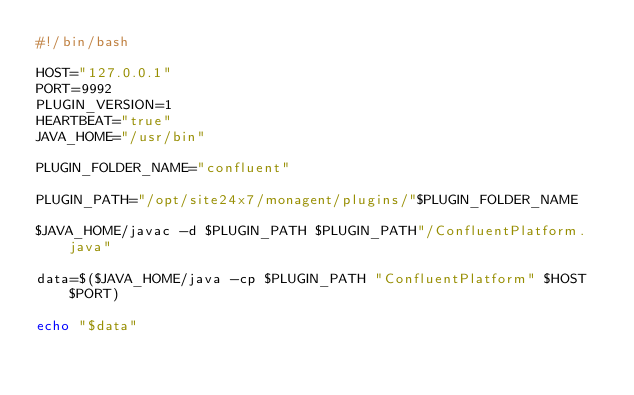<code> <loc_0><loc_0><loc_500><loc_500><_Bash_>#!/bin/bash

HOST="127.0.0.1"
PORT=9992
PLUGIN_VERSION=1
HEARTBEAT="true"
JAVA_HOME="/usr/bin"

PLUGIN_FOLDER_NAME="confluent"

PLUGIN_PATH="/opt/site24x7/monagent/plugins/"$PLUGIN_FOLDER_NAME

$JAVA_HOME/javac -d $PLUGIN_PATH $PLUGIN_PATH"/ConfluentPlatform.java"

data=$($JAVA_HOME/java -cp $PLUGIN_PATH "ConfluentPlatform" $HOST $PORT)

echo "$data"

</code> 